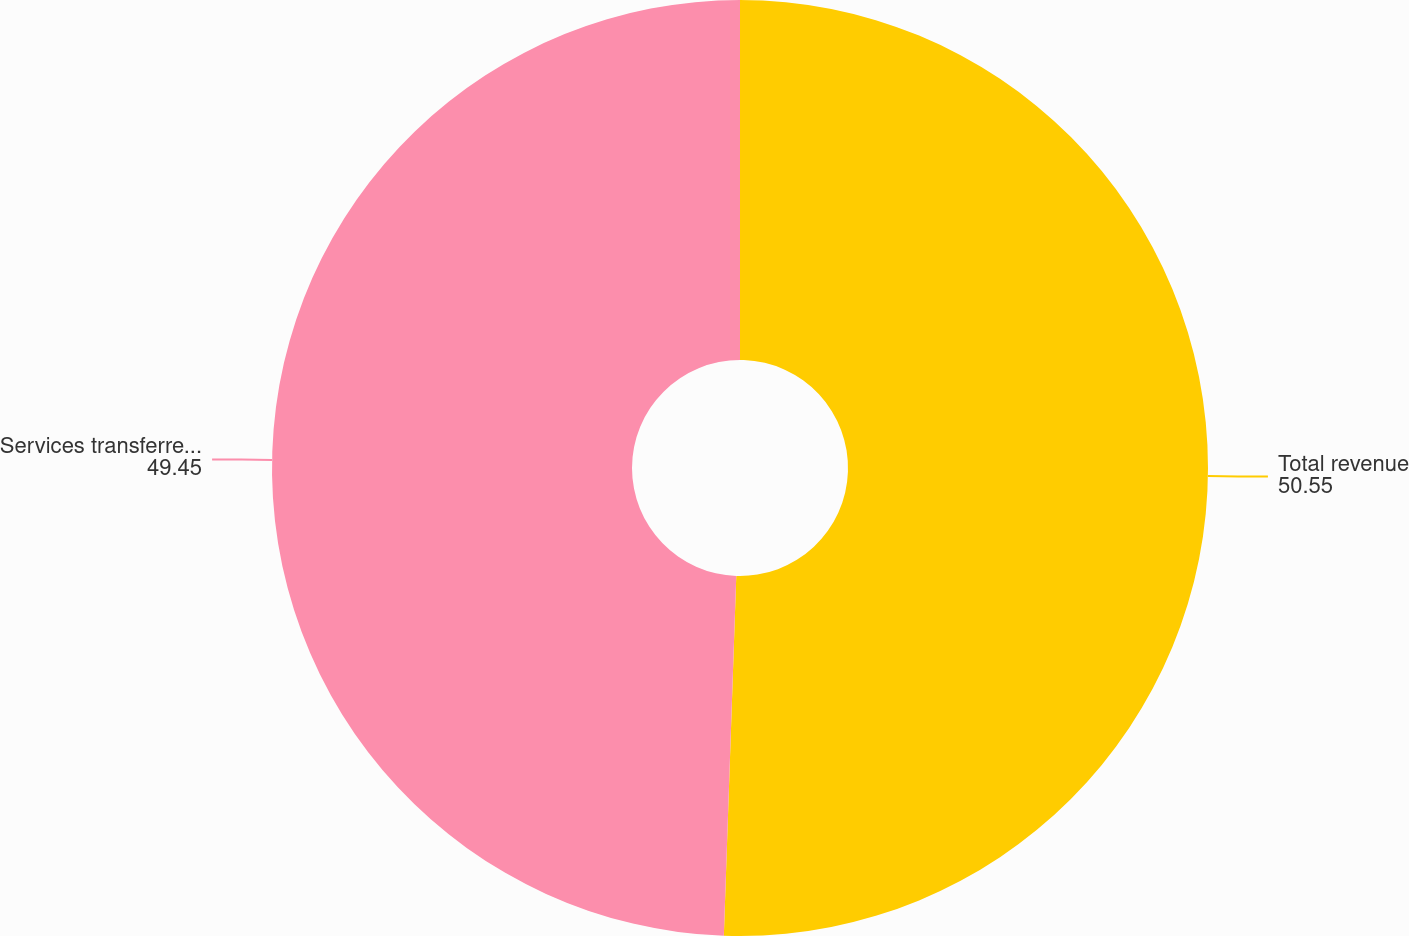<chart> <loc_0><loc_0><loc_500><loc_500><pie_chart><fcel>Total revenue<fcel>Services transferred over time<nl><fcel>50.55%<fcel>49.45%<nl></chart> 